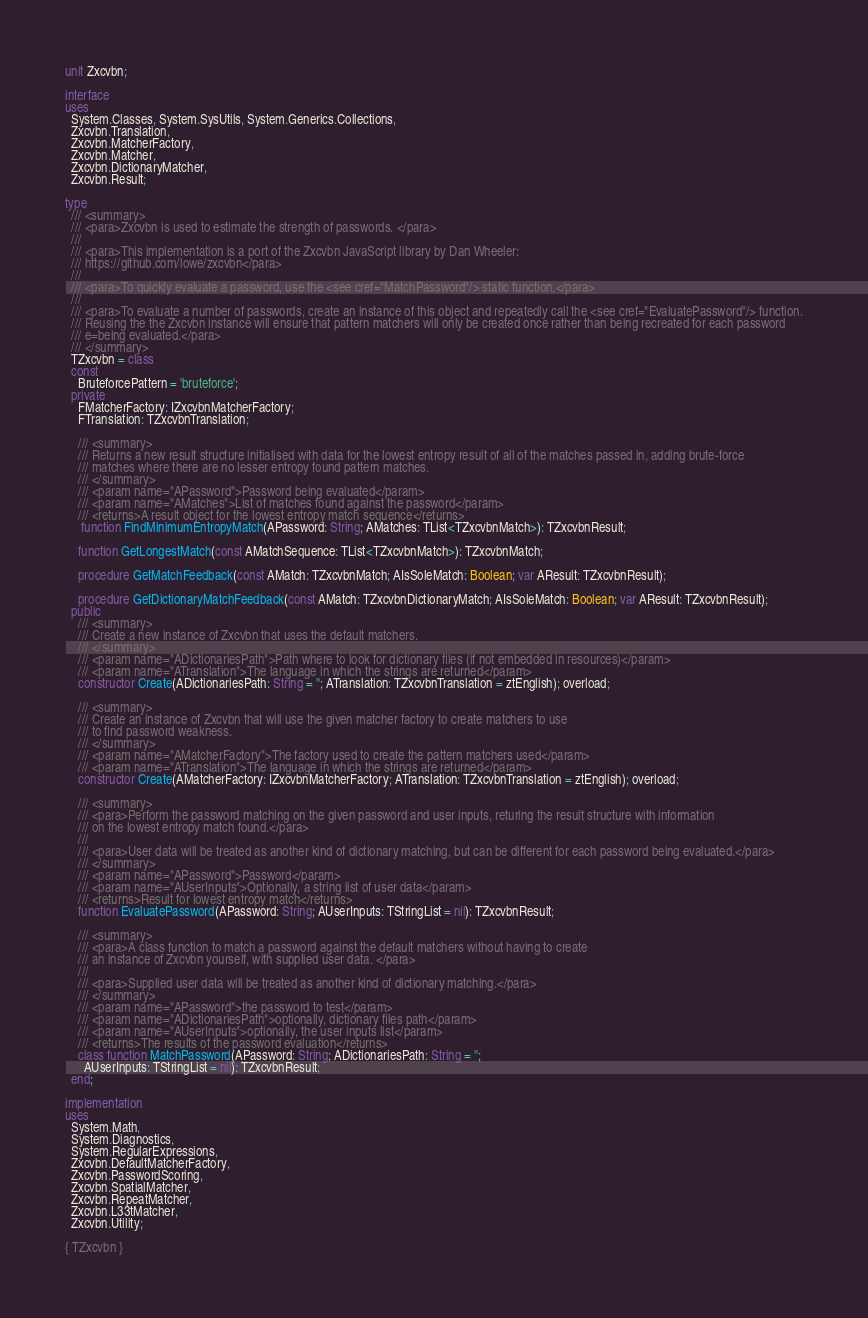<code> <loc_0><loc_0><loc_500><loc_500><_Pascal_>unit Zxcvbn;

interface
uses
  System.Classes, System.SysUtils, System.Generics.Collections,
  Zxcvbn.Translation,
  Zxcvbn.MatcherFactory,
  Zxcvbn.Matcher,
  Zxcvbn.DictionaryMatcher,
  Zxcvbn.Result;

type
  /// <summary>
  /// <para>Zxcvbn is used to estimate the strength of passwords. </para>
  ///
  /// <para>This implementation is a port of the Zxcvbn JavaScript library by Dan Wheeler:
  /// https://github.com/lowe/zxcvbn</para>
  ///
  /// <para>To quickly evaluate a password, use the <see cref="MatchPassword"/> static function.</para>
  ///
  /// <para>To evaluate a number of passwords, create an instance of this object and repeatedly call the <see cref="EvaluatePassword"/> function.
  /// Reusing the the Zxcvbn instance will ensure that pattern matchers will only be created once rather than being recreated for each password
  /// e=being evaluated.</para>
  /// </summary>
  TZxcvbn = class
  const
    BruteforcePattern = 'bruteforce';
  private
    FMatcherFactory: IZxcvbnMatcherFactory;
    FTranslation: TZxcvbnTranslation;

    /// <summary>
    /// Returns a new result structure initialised with data for the lowest entropy result of all of the matches passed in, adding brute-force
    /// matches where there are no lesser entropy found pattern matches.
    /// </summary>
    /// <param name="APassword">Password being evaluated</param>
    /// <param name="AMatches">List of matches found against the password</param>
    /// <returns>A result object for the lowest entropy match sequence</returns>
	 function FindMinimumEntropyMatch(APassword: String; AMatches: TList<TZxcvbnMatch>): TZxcvbnResult;

    function GetLongestMatch(const AMatchSequence: TList<TZxcvbnMatch>): TZxcvbnMatch;

    procedure GetMatchFeedback(const AMatch: TZxcvbnMatch; AIsSoleMatch: Boolean; var AResult: TZxcvbnResult);

    procedure GetDictionaryMatchFeedback(const AMatch: TZxcvbnDictionaryMatch; AIsSoleMatch: Boolean; var AResult: TZxcvbnResult);
  public
    /// <summary>
    /// Create a new instance of Zxcvbn that uses the default matchers.
    /// </summary>
    /// <param name="ADictionariesPath">Path where to look for dictionary files (if not embedded in resources)</param>
    /// <param name="ATranslation">The language in which the strings are returned</param>
    constructor Create(ADictionariesPath: String = ''; ATranslation: TZxcvbnTranslation = ztEnglish); overload;

    /// <summary>
    /// Create an instance of Zxcvbn that will use the given matcher factory to create matchers to use
    /// to find password weakness.
    /// </summary>
    /// <param name="AMatcherFactory">The factory used to create the pattern matchers used</param>
    /// <param name="ATranslation">The language in which the strings are returned</param>
    constructor Create(AMatcherFactory: IZxcvbnMatcherFactory; ATranslation: TZxcvbnTranslation = ztEnglish); overload;

    /// <summary>
    /// <para>Perform the password matching on the given password and user inputs, returing the result structure with information
    /// on the lowest entropy match found.</para>
    ///
    /// <para>User data will be treated as another kind of dictionary matching, but can be different for each password being evaluated.</para>
    /// </summary>
    /// <param name="APassword">Password</param>
    /// <param name="AUserInputs">Optionally, a string list of user data</param>
    /// <returns>Result for lowest entropy match</returns>
    function EvaluatePassword(APassword: String; AUserInputs: TStringList = nil): TZxcvbnResult;

    /// <summary>
    /// <para>A class function to match a password against the default matchers without having to create
    /// an instance of Zxcvbn yourself, with supplied user data. </para>
    ///
    /// <para>Supplied user data will be treated as another kind of dictionary matching.</para>
    /// </summary>
    /// <param name="APassword">the password to test</param>
    /// <param name="ADictionariesPath">optionally, dictionary files path</param>
    /// <param name="AUserInputs">optionally, the user inputs list</param>
    /// <returns>The results of the password evaluation</returns>
    class function MatchPassword(APassword: String; ADictionariesPath: String = '';
      AUserInputs: TStringList = nil): TZxcvbnResult;
  end;

implementation
uses
  System.Math,
  System.Diagnostics,
  System.RegularExpressions,
  Zxcvbn.DefaultMatcherFactory,
  Zxcvbn.PasswordScoring,
  Zxcvbn.SpatialMatcher,
  Zxcvbn.RepeatMatcher,
  Zxcvbn.L33tMatcher,
  Zxcvbn.Utility;

{ TZxcvbn }
</code> 